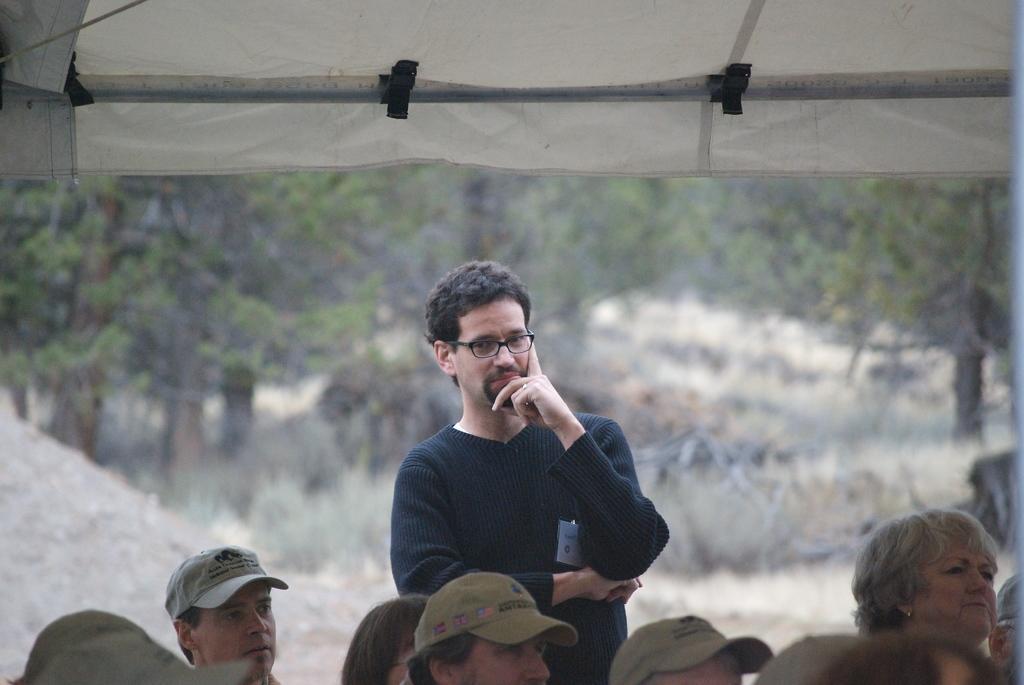Please provide a concise description of this image. In the center of the image a man is standing. At the bottom of the image group of people are there and some of them are wearing hats. In the background of the image trees are present. At the top of the image tent is there. In the middle of the image ground is present. 